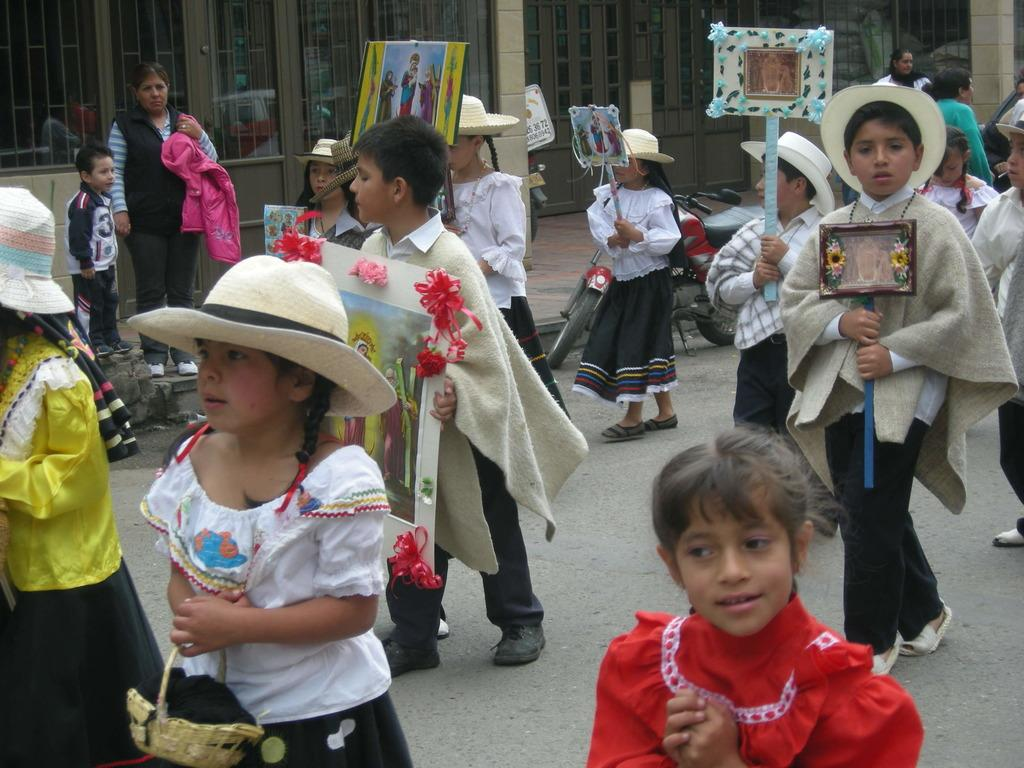What can be seen in the image? There are children in the image. What are the children holding? The children are holding posters. What structure is visible at the top side of the image? There is a building at the top side of the image. How many feet are visible on the children in the image? The number of feet visible on the children cannot be determined from the image, as feet are not shown. 